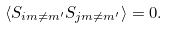Convert formula to latex. <formula><loc_0><loc_0><loc_500><loc_500>\langle S _ { i m \ne m ^ { \prime } } S _ { j m \ne m ^ { \prime } } \rangle = 0 .</formula> 